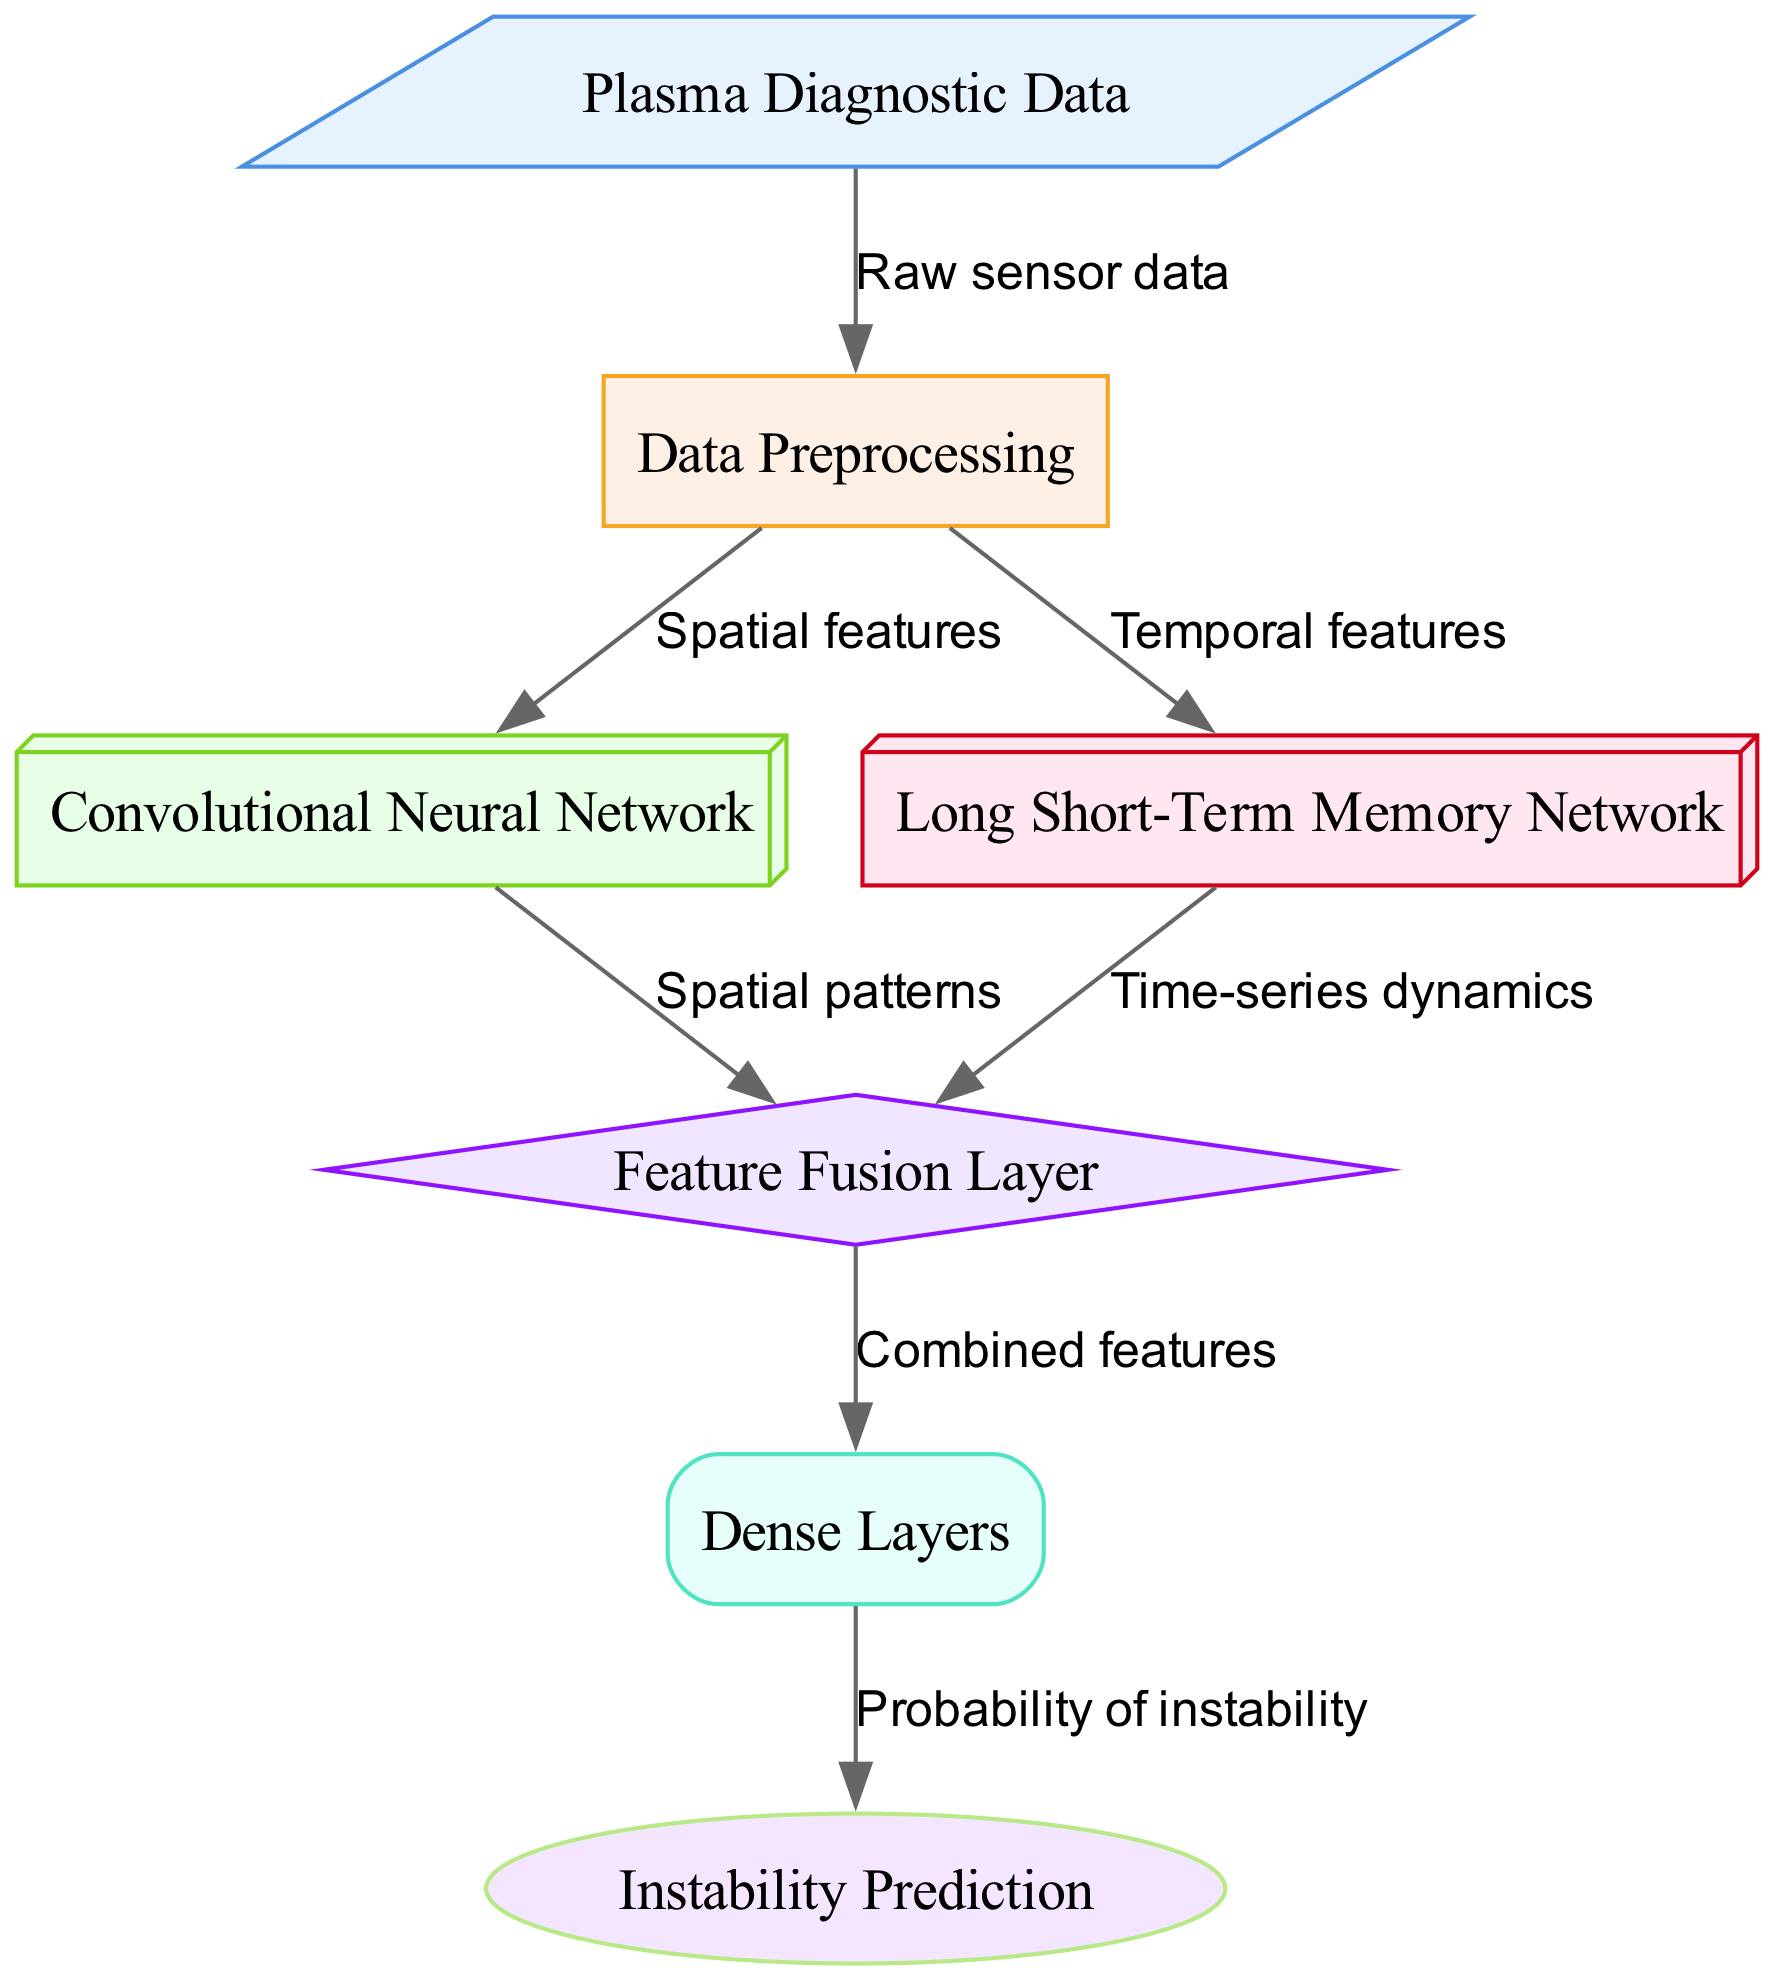What is the first step in the diagram? The diagram indicates that the first step is to process the "Plasma Diagnostic Data" as shown by the arrow from the "input" node to the "preprocess" node.
Answer: Data Preprocessing How many types of networks are used in the architecture? The diagram includes two types of networks, which are the "Convolutional Neural Network" and the "Long Short-Term Memory Network".
Answer: Two What do the CNN and LSTM nodes output? The "Convolutional Neural Network" outputs "Spatial patterns" while the "Long Short-Term Memory Network" outputs "Time-series dynamics", as indicated by the arrows leading to the "Feature Fusion Layer".
Answer: Spatial patterns and Time-series dynamics What is the final output of this diagram? The last node in the flow is labeled "Instability Prediction", indicating that this is the final output after processing through all previously mentioned nodes.
Answer: Instability Prediction What layer combines the features from CNN and LSTM? The diagram shows that the "Feature Fusion Layer" is responsible for combining the outputs from the "Convolutional Neural Network" and the "Long Short-Term Memory Network".
Answer: Feature Fusion Layer What type of data does the 'Dense Layers' receive? The 'Dense Layers' receive "Combined features" as indicated by the connection from the "Feature Fusion Layer" to the "Dense Layers".
Answer: Combined features What type of node is used for representing the input data? The input data is represented by a "parallelogram" shaped node as per the node attributes outlined in the diagram.
Answer: Parallelogram Which layer is responsible for the final predictions? The "Dense Layers" are shown as the final processing point before the output, hence responsible for making the final predictions about instabilities.
Answer: Dense Layers In total, how many edges are present in the diagram? By counting the arrows indicating the flow of information from one node to another, there are a total of six edges in the diagram.
Answer: Six 